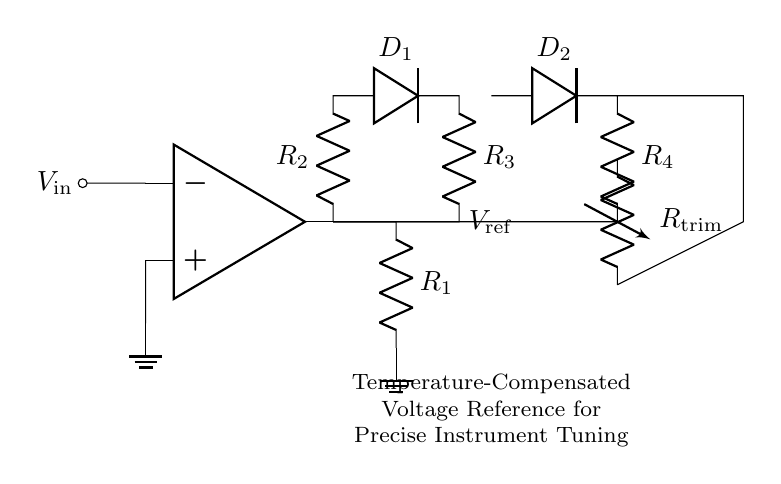What is the input voltage of this circuit? The input voltage is labeled as $V_{\text{in}}$ and is connected to the inverting input of the operational amplifier.
Answer: V in What type of component is used for temperature sensing? The circuit includes a thermistor, which is specifically designed for temperature measurement and compensation.
Answer: Thermistor What is the purpose of resistor R trim? R trim is a variable resistor used for fine-tuning the output voltage reference to achieve precise calibration as needed.
Answer: Fine-tuning How many diodes are present in the circuit? There are two diodes, labeled as D1 and D2, which are part of the temperature compensation network surrounding the operational amplifier.
Answer: 2 What does the output voltage $V_{\text{ref}}$ represent? The output voltage labeled $V_{\text{ref}}$ is the precise voltage reference generated by the circuit for tuning electronic instruments.
Answer: Voltage reference Which component connects to the non-inverting input of the operational amplifier? The non-inverting input is connected to ground, which is standard for voltage reference circuits ensuring a stable reference point.
Answer: Ground How does the temperature compensation network affect the output? The temperature compensation network, comprised of resistors and diodes, stabilizes the output voltage against temperature variations, ensuring accuracy.
Answer: Stabilizes output 